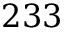Convert formula to latex. <formula><loc_0><loc_0><loc_500><loc_500>2 3 3</formula> 